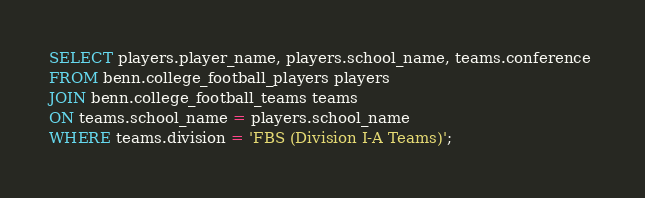<code> <loc_0><loc_0><loc_500><loc_500><_SQL_>SELECT players.player_name, players.school_name, teams.conference 
FROM benn.college_football_players players
JOIN benn.college_football_teams teams
ON teams.school_name = players.school_name
WHERE teams.division = 'FBS (Division I-A Teams)';
</code> 